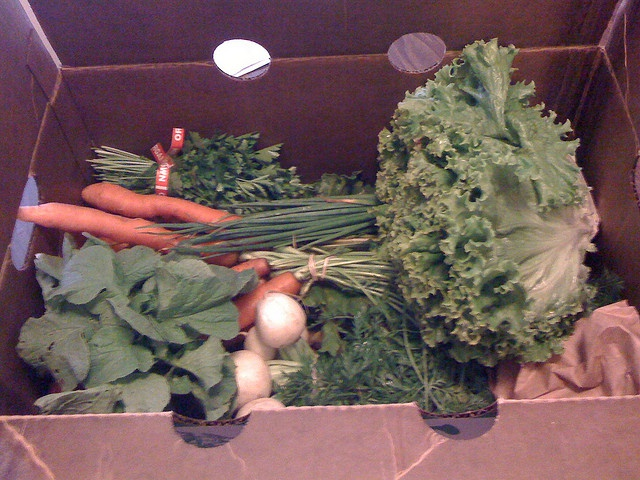Describe the objects in this image and their specific colors. I can see broccoli in gray, tan, and black tones, carrot in gray, salmon, and brown tones, carrot in gray, salmon, brown, and maroon tones, carrot in gray, brown, salmon, and maroon tones, and carrot in gray, maroon, purple, and brown tones in this image. 